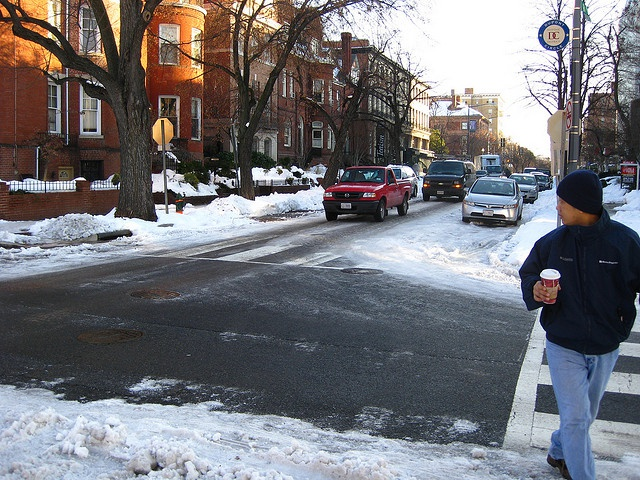Describe the objects in this image and their specific colors. I can see people in black, gray, and navy tones, truck in black, maroon, gray, and brown tones, car in black, gray, and darkgray tones, truck in black, navy, gray, and blue tones, and car in black, navy, blue, and gray tones in this image. 